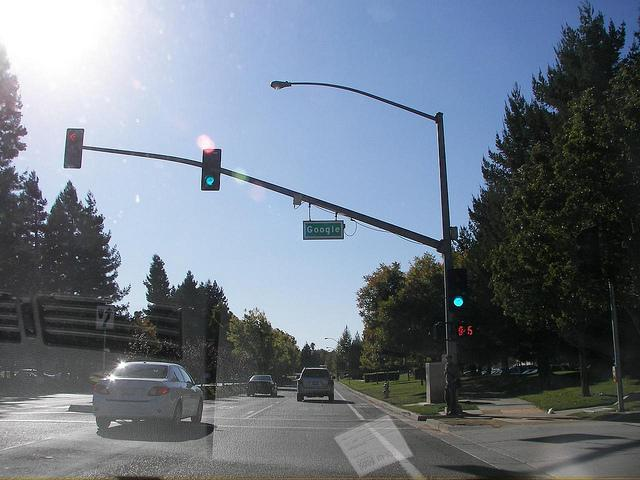What street is marked by the traffic light?

Choices:
A) google
B) apple
C) facebook
D) alphabet google 